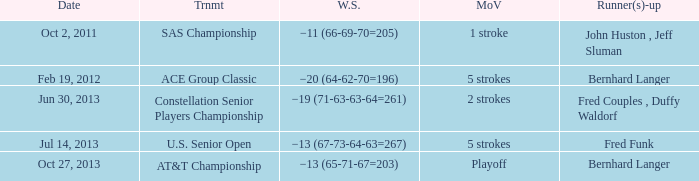When was there a 5-stroke victory margin with a -13 (67-73-64-63=267) winning score? Jul 14, 2013. 